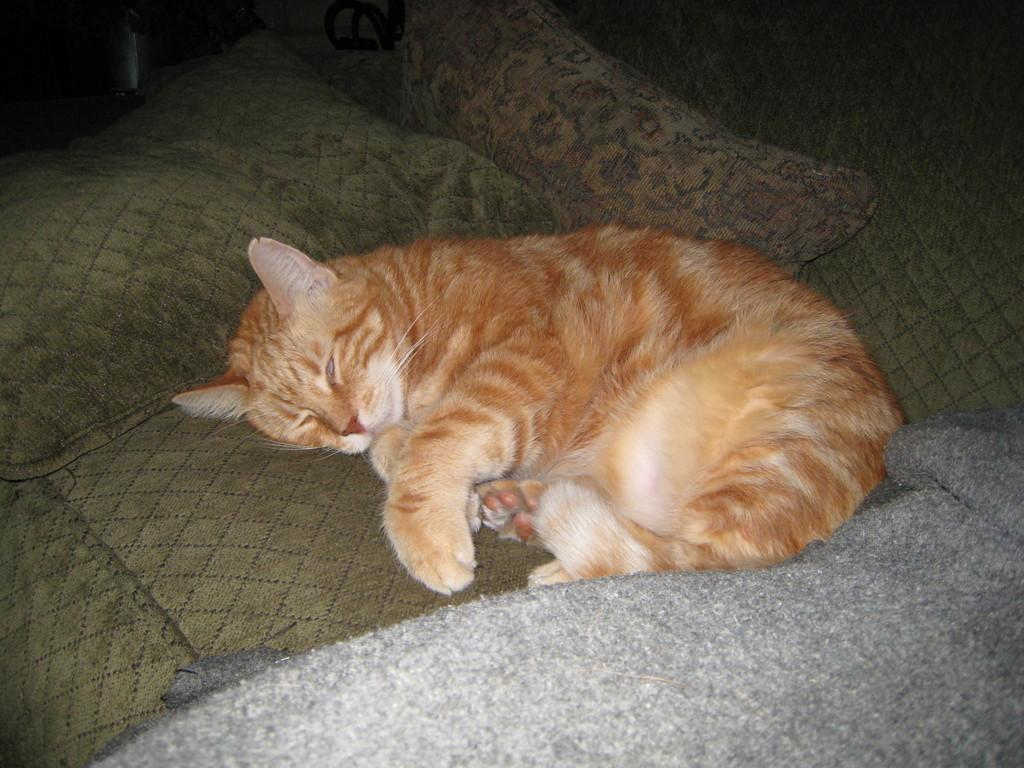What type of animal is in the image? There is a cat in the image. What is the cat doing in the image? The cat is sleeping. Where is the cat located in the image? The cat is on a couch. What type of boat is the cat sailing in the image? There is no boat present in the image; the cat is on a couch. What division of mathematics is the cat studying in the image? There is no indication that the cat is studying any subject, let alone a division of mathematics. 